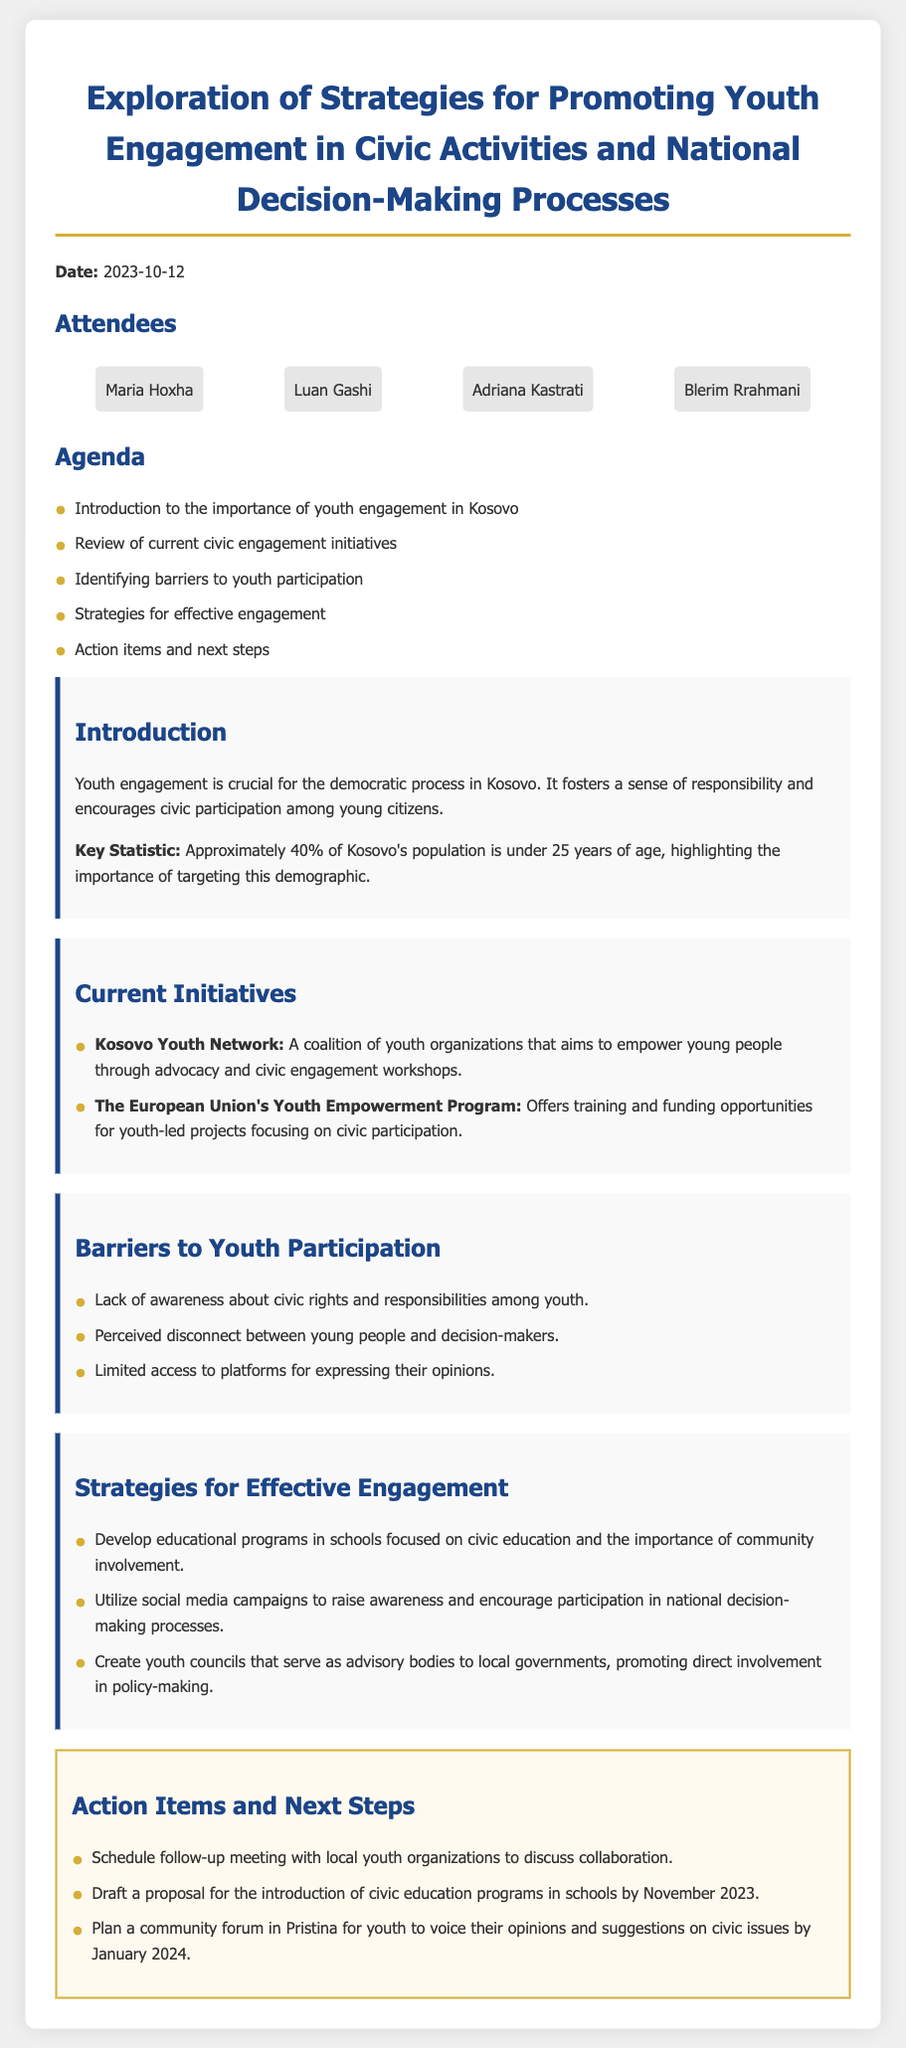what is the date of the meeting? The date is mentioned at the top of the document as "2023-10-12".
Answer: 2023-10-12 who are two attendees at the meeting? The attendees are listed, and two of them mentioned are "Maria Hoxha" and "Luan Gashi".
Answer: Maria Hoxha, Luan Gashi how many key statistics are mentioned in the document? The document highlights one key statistic regarding the population under 25 years old, which is approximately 40%.
Answer: 1 what is the first barrier to youth participation identified? The barriers to participation are enumerated, and the first one mentioned is "Lack of awareness about civic rights and responsibilities among youth."
Answer: Lack of awareness about civic rights and responsibilities among youth what strategy involves social media? The strategies for engagement discussed include "Utilize social media campaigns to raise awareness and encourage participation in national decision-making processes."
Answer: Utilize social media campaigns what is one action item listed for follow-up? The action items include "Schedule follow-up meeting with local youth organizations to discuss collaboration."
Answer: Schedule follow-up meeting what is the purpose of the Kosovo Youth Network? The purpose is defined in the current initiatives section, which states, "A coalition of youth organizations that aims to empower young people through advocacy and civic engagement workshops."
Answer: Empower young people through advocacy and civic engagement workshops how many attendees are named in the document? The document lists a total of four attendees specified under the attendees section.
Answer: 4 which month is the proposed civic education programs draft due? The action items specify that the draft proposal is due "by November 2023."
Answer: November 2023 